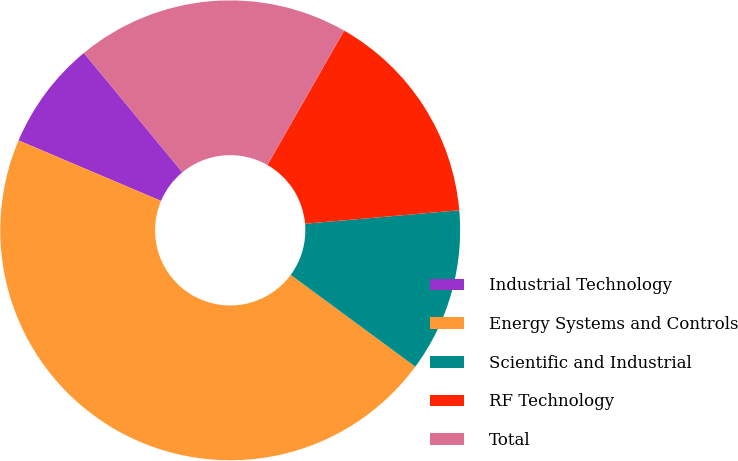Convert chart to OTSL. <chart><loc_0><loc_0><loc_500><loc_500><pie_chart><fcel>Industrial Technology<fcel>Energy Systems and Controls<fcel>Scientific and Industrial<fcel>RF Technology<fcel>Total<nl><fcel>7.63%<fcel>46.29%<fcel>11.49%<fcel>15.36%<fcel>19.23%<nl></chart> 